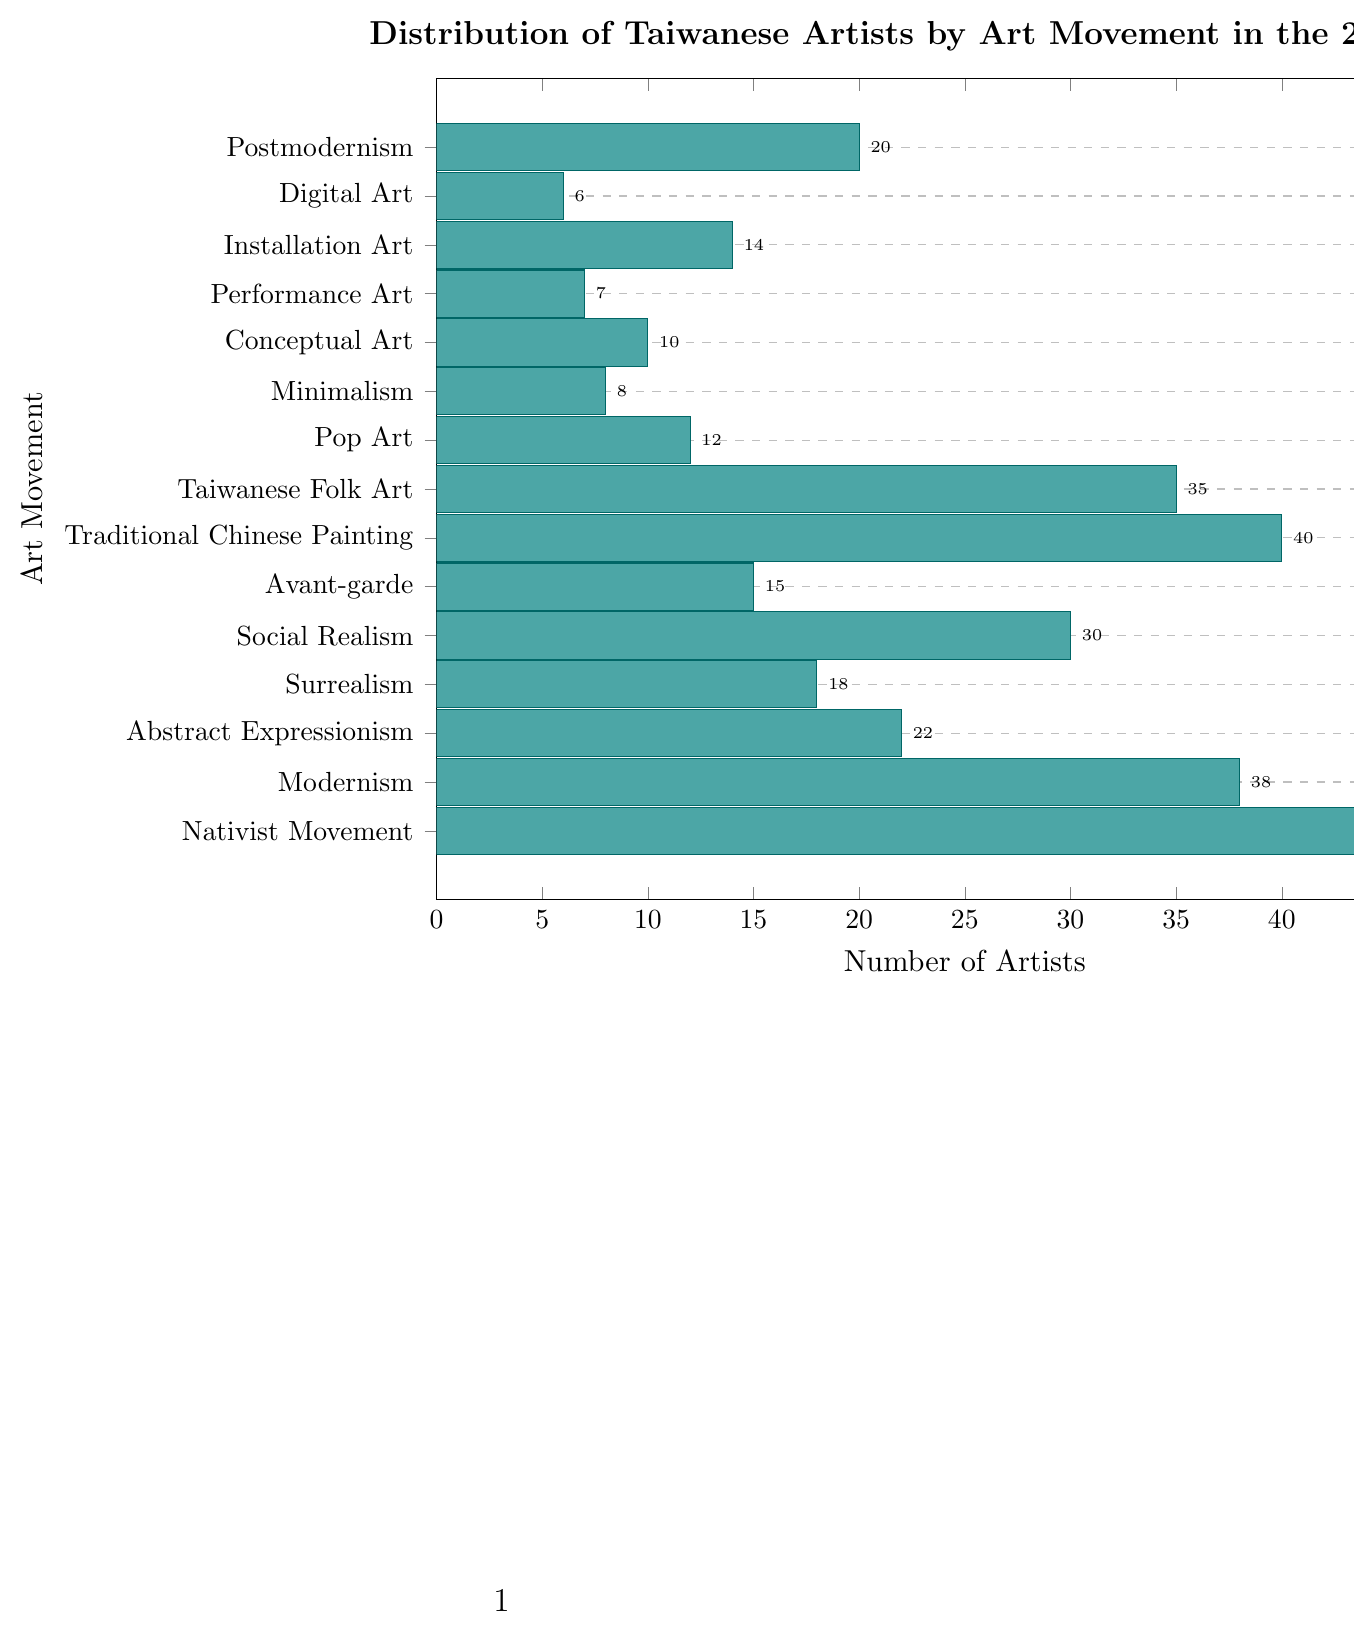Which art movement had the highest number of Taiwanese artists in the 20th century? Refer to the bar heights. The tallest bar represents the "Nativist Movement" with 45 artists.
Answer: Nativist Movement How many more artists were there in the Nativist Movement compared to Modernism? Subtract the number of Modernism artists from Nativist Movement artists: 45 - 38 = 7.
Answer: 7 What's the total number of artists in Abstract Expressionism, Surrealism, and Pop Art combined? Add the numbers for Abstract Expressionism (22), Surrealism (18), and Pop Art (12): 22 + 18 + 12 = 52.
Answer: 52 Which art movements had fewer than 10 artists? Identify bars shorter than the one representing "10": Minimalism (8), Performance Art (7), and Digital Art (6)
Answer: Minimalism, Performance Art, Digital Art How does the number of artists in Taiwanese Folk Art compare to Traditional Chinese Painting? Taiwanese Folk Art has 35 artists, whereas Traditional Chinese Painting has 40 artists. The latter has 5 more artists.
Answer: Traditional Chinese Painting has 5 more artists What's the average number of artists across all art movements? Sum all artist numbers: 45 + 38 + 22 + 18 + 30 + 15 + 40 + 35 + 12 + 8 + 10 + 7 + 14 + 6 + 20 = 320. Divide by the number of movements (15): 320 / 15 ≈ 21.33.
Answer: ~21.33 Arrange the movements Avant-garde, Social Realism, and Surrealism in descending order of the number of artists. Identify their numbers: Avant-garde (15), Social Realism (30), Surrealism (18). Order: Social Realism, Surrealism, Avant-garde.
Answer: Social Realism, Surrealism, Avant-garde Which art movement had the fewest Taiwanese artists in the 20th century? The shortest bar is "Digital Art" with 6 artists.
Answer: Digital Art How many artists are represented by the combined total of Performance Art and Installation Art? Add the numbers for Performance Art (7) and Installation Art (14): 7 + 14 = 21.
Answer: 21 If you combine the number of artists in Nativist Movement and Modernism, how many more is it than Postmodernism? Add Nativist Movement (45) and Modernism (38): 45 + 38 = 83. Subtract Postmodernism (20): 83 - 20 = 63.
Answer: 63 